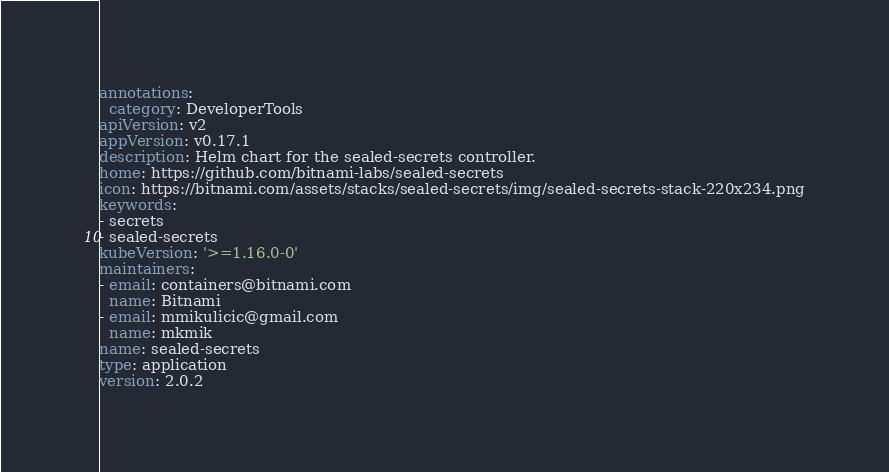<code> <loc_0><loc_0><loc_500><loc_500><_YAML_>annotations:
  category: DeveloperTools
apiVersion: v2
appVersion: v0.17.1
description: Helm chart for the sealed-secrets controller.
home: https://github.com/bitnami-labs/sealed-secrets
icon: https://bitnami.com/assets/stacks/sealed-secrets/img/sealed-secrets-stack-220x234.png
keywords:
- secrets
- sealed-secrets
kubeVersion: '>=1.16.0-0'
maintainers:
- email: containers@bitnami.com
  name: Bitnami
- email: mmikulicic@gmail.com
  name: mkmik
name: sealed-secrets
type: application
version: 2.0.2
</code> 